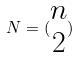Convert formula to latex. <formula><loc_0><loc_0><loc_500><loc_500>N = ( \begin{matrix} n \\ 2 \end{matrix} )</formula> 